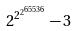Convert formula to latex. <formula><loc_0><loc_0><loc_500><loc_500>2 ^ { 2 ^ { 2 ^ { 6 5 5 3 6 } } } - 3</formula> 